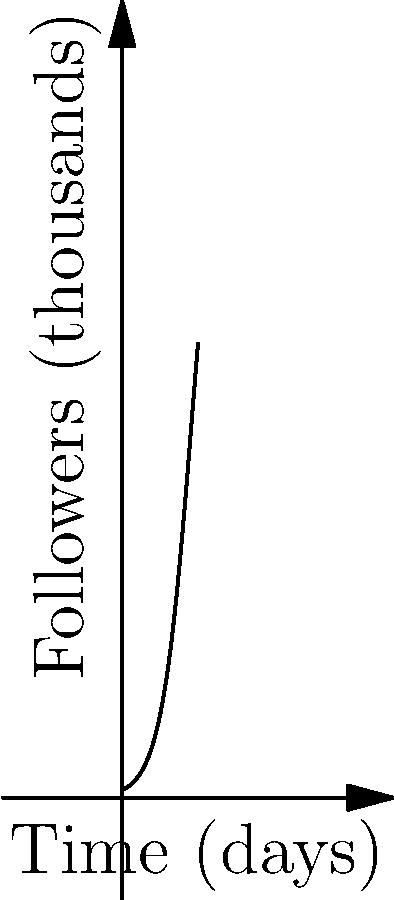Your roommate's latest song has gone viral on social media. The graph shows the growth of followers over time. If the trend continues, approximately how many more days will it take to reach point C from point B? To solve this problem, we need to understand the concept of exponential growth in social media trends:

1. The graph represents a logistic growth curve, which is common in viral trends.

2. We need to estimate the time difference between points B and C.

3. Point B appears to be around day 5, and point C around day 8.

4. The time difference is approximately 8 - 5 = 3 days.

5. While the growth isn't perfectly linear, for a quick estimate in this context, we can assume it's roughly consistent between these two points.

This estimation method aligns with the business perspective of quick, actionable insights rather than precise mathematical calculations.
Answer: Approximately 3 days 